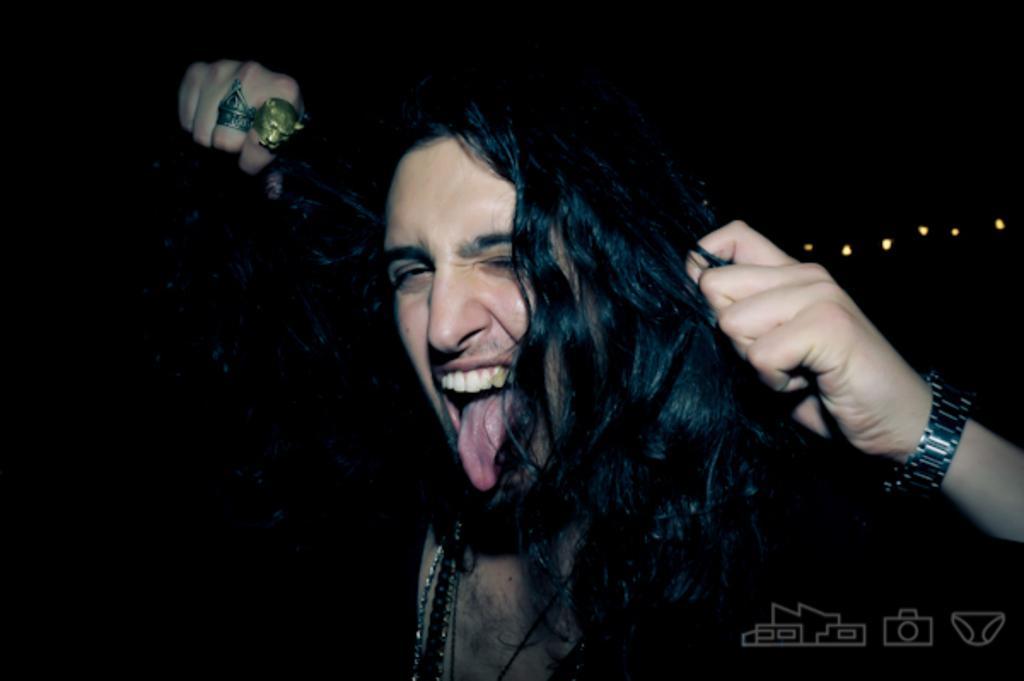Can you describe this image briefly? In this image there is a person who is keeping his tongue outside by holding the hair with his left hand. To the right hand there are two rings. 